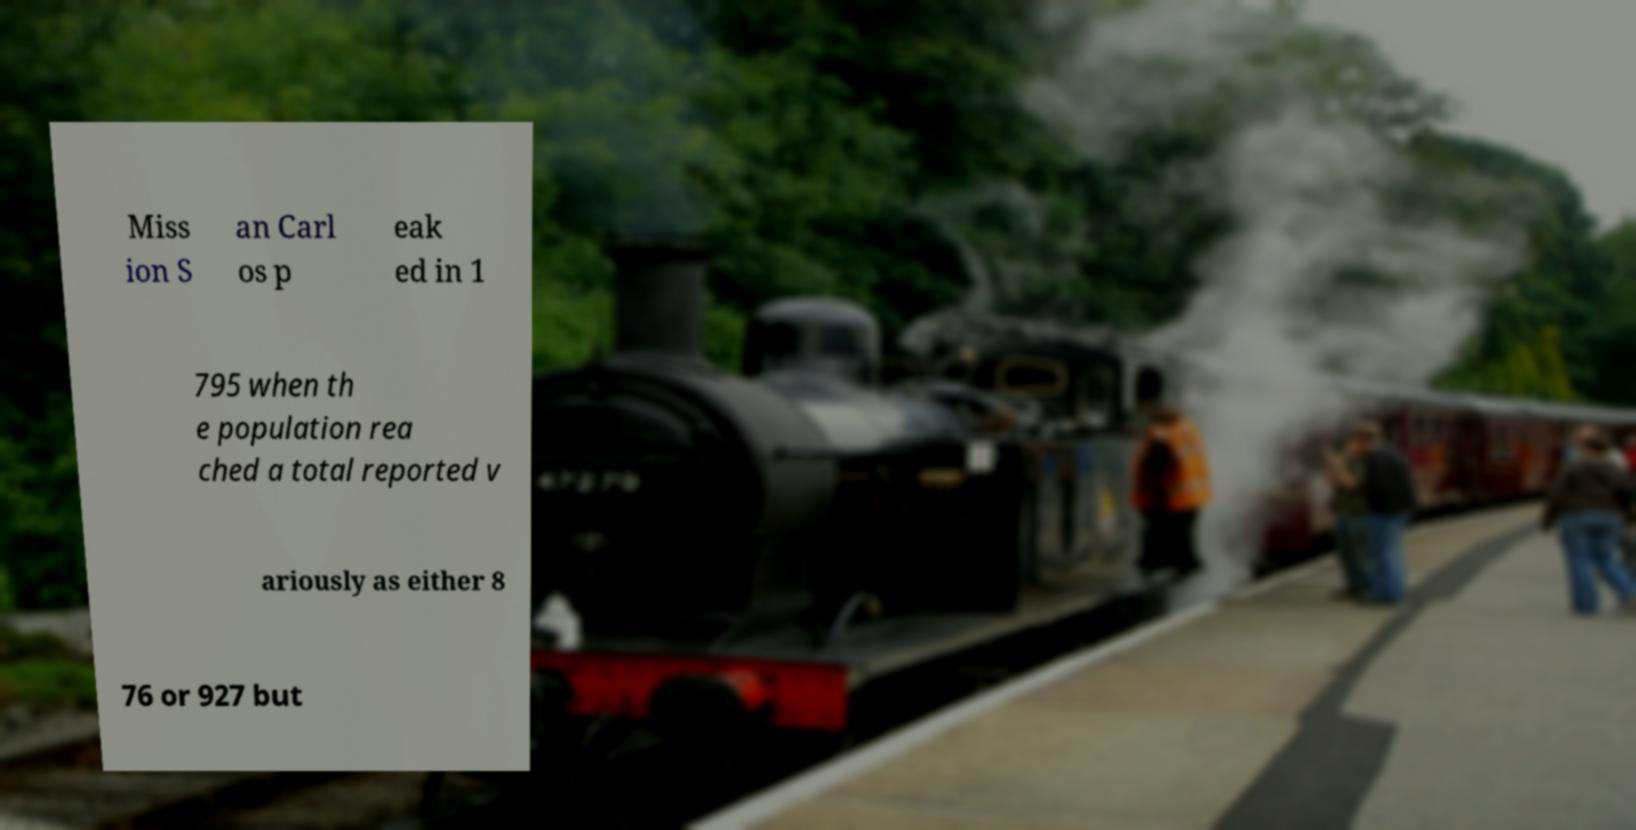Could you assist in decoding the text presented in this image and type it out clearly? Miss ion S an Carl os p eak ed in 1 795 when th e population rea ched a total reported v ariously as either 8 76 or 927 but 